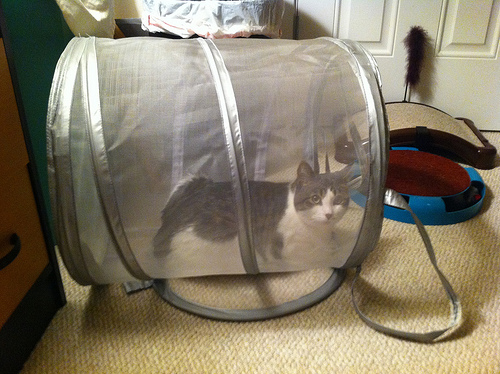<image>
Can you confirm if the cat is in the laundry basket? Yes. The cat is contained within or inside the laundry basket, showing a containment relationship. Is the cage in front of the cat? No. The cage is not in front of the cat. The spatial positioning shows a different relationship between these objects. 